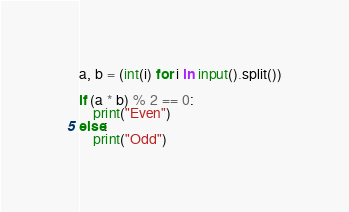<code> <loc_0><loc_0><loc_500><loc_500><_Python_>a, b = (int(i) for i in input().split())

if (a * b) % 2 == 0:
    print("Even")
else:
    print("Odd")</code> 